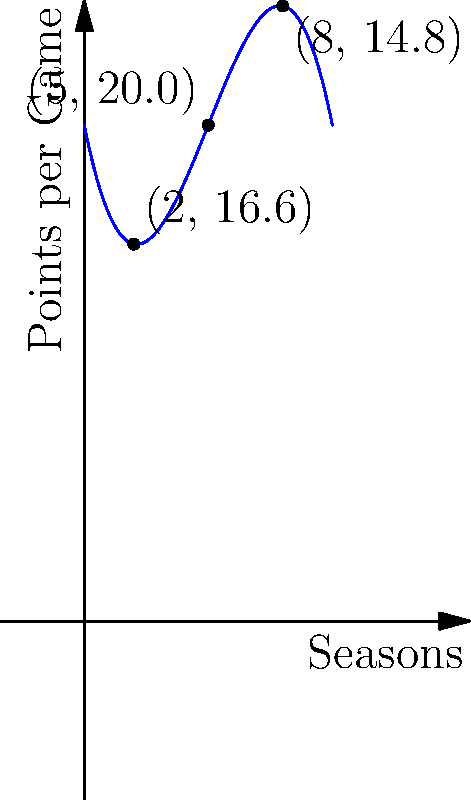The graph above represents a player's scoring average (in points per game) over several seasons, modeled by a third-degree polynomial. If this trend continues, in which season would the player's scoring average be expected to peak? To find the season when the player's scoring average peaks, we need to follow these steps:

1) The graph represents a third-degree polynomial function. Let's call this function $f(x)$, where $x$ represents the season number and $f(x)$ represents the points per game.

2) The peak of the function occurs at the maximum point of the curve. At this point, the derivative of the function equals zero: $f'(x) = 0$.

3) For a third-degree polynomial of the form $f(x) = ax^3 + bx^2 + cx + d$, the derivative is $f'(x) = 3ax^2 + 2bx + c$.

4) Setting $f'(x) = 0$ and solving for $x$ will give us the $x$-coordinate of the maximum point.

5) From the graph, we can estimate that the peak occurs around season 5.

6) To verify this mathematically, we'd need the exact coefficients of the polynomial. However, we can see from the graph that the function reaches its highest point near $x = 5$.

Therefore, based on the graph, the player's scoring average is expected to peak around the 5th season.
Answer: 5th season 